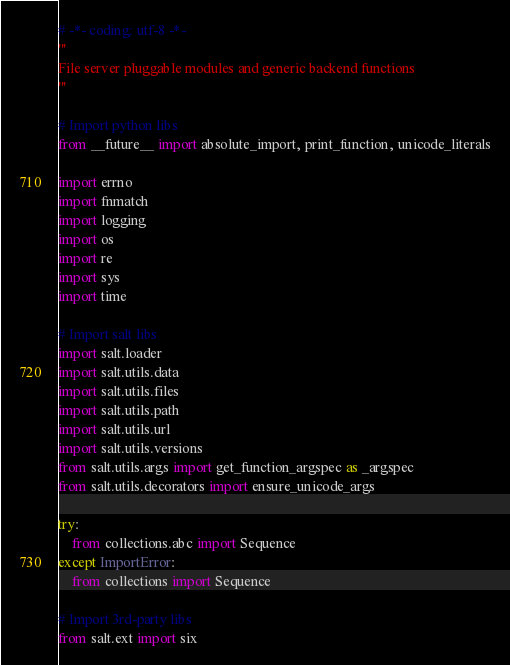<code> <loc_0><loc_0><loc_500><loc_500><_Python_># -*- coding: utf-8 -*-
'''
File server pluggable modules and generic backend functions
'''

# Import python libs
from __future__ import absolute_import, print_function, unicode_literals

import errno
import fnmatch
import logging
import os
import re
import sys
import time

# Import salt libs
import salt.loader
import salt.utils.data
import salt.utils.files
import salt.utils.path
import salt.utils.url
import salt.utils.versions
from salt.utils.args import get_function_argspec as _argspec
from salt.utils.decorators import ensure_unicode_args

try:
    from collections.abc import Sequence
except ImportError:
    from collections import Sequence

# Import 3rd-party libs
from salt.ext import six

</code> 